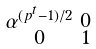<formula> <loc_0><loc_0><loc_500><loc_500>\begin{smallmatrix} \alpha ^ { ( p ^ { t } - 1 ) / 2 } & 0 \\ 0 & 1 \end{smallmatrix}</formula> 